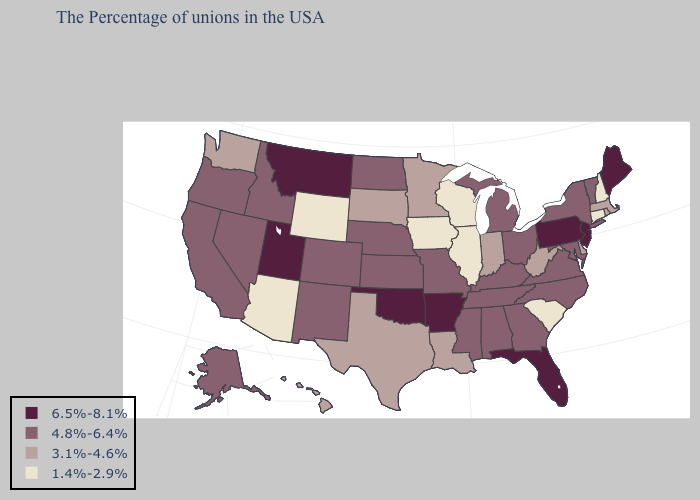Name the states that have a value in the range 4.8%-6.4%?
Keep it brief. Vermont, New York, Maryland, Virginia, North Carolina, Ohio, Georgia, Michigan, Kentucky, Alabama, Tennessee, Mississippi, Missouri, Kansas, Nebraska, North Dakota, Colorado, New Mexico, Idaho, Nevada, California, Oregon, Alaska. Does the map have missing data?
Concise answer only. No. What is the value of Oregon?
Answer briefly. 4.8%-6.4%. Name the states that have a value in the range 1.4%-2.9%?
Be succinct. New Hampshire, Connecticut, South Carolina, Wisconsin, Illinois, Iowa, Wyoming, Arizona. Does Wyoming have the same value as Arizona?
Be succinct. Yes. What is the value of Georgia?
Write a very short answer. 4.8%-6.4%. Does South Dakota have a lower value than Pennsylvania?
Write a very short answer. Yes. What is the value of Massachusetts?
Keep it brief. 3.1%-4.6%. What is the value of Indiana?
Answer briefly. 3.1%-4.6%. Does Vermont have the lowest value in the Northeast?
Short answer required. No. Name the states that have a value in the range 3.1%-4.6%?
Short answer required. Massachusetts, Rhode Island, Delaware, West Virginia, Indiana, Louisiana, Minnesota, Texas, South Dakota, Washington, Hawaii. Name the states that have a value in the range 1.4%-2.9%?
Short answer required. New Hampshire, Connecticut, South Carolina, Wisconsin, Illinois, Iowa, Wyoming, Arizona. Among the states that border Nebraska , which have the lowest value?
Give a very brief answer. Iowa, Wyoming. How many symbols are there in the legend?
Answer briefly. 4. Is the legend a continuous bar?
Keep it brief. No. 